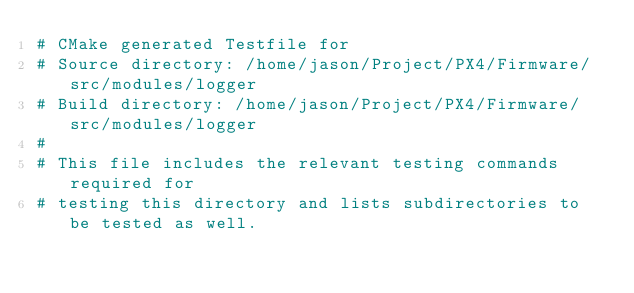<code> <loc_0><loc_0><loc_500><loc_500><_CMake_># CMake generated Testfile for 
# Source directory: /home/jason/Project/PX4/Firmware/src/modules/logger
# Build directory: /home/jason/Project/PX4/Firmware/src/modules/logger
# 
# This file includes the relevant testing commands required for 
# testing this directory and lists subdirectories to be tested as well.
</code> 